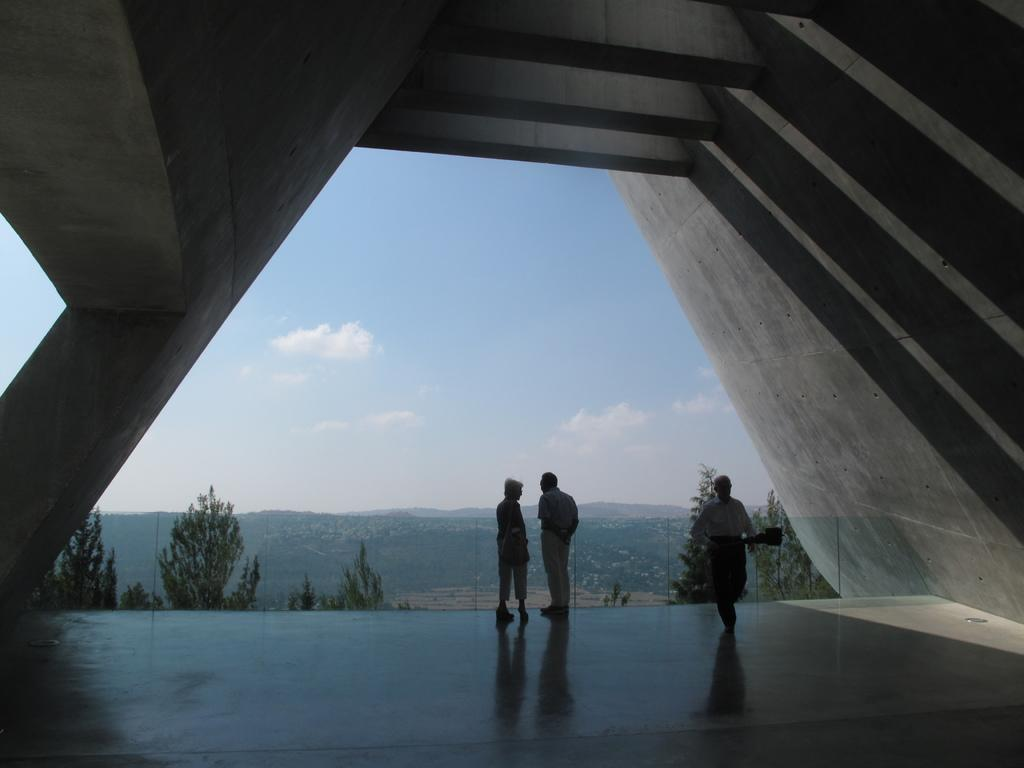What type of architecture is visible in the image? There is a cement architecture in the image. Who or what can be seen at the bottom of the image? There are people at the bottom of the image. Can you describe the actions of one of the people in the image? One person is holding a bag. What can be seen in the background of the image? There are trees, hills, and the sky with clouds visible in the background of the image. How many attempts does the person make to clean the floor with dust in the image? There is no mention of a floor, dust, or attempts to clean in the image. 